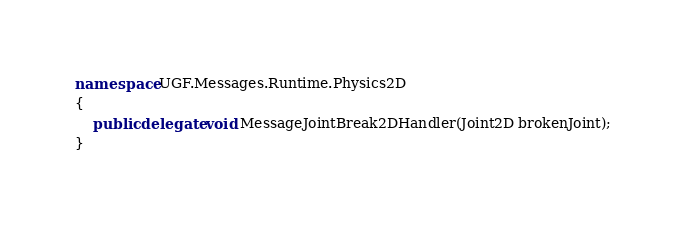Convert code to text. <code><loc_0><loc_0><loc_500><loc_500><_C#_>namespace UGF.Messages.Runtime.Physics2D
{
    public delegate void MessageJointBreak2DHandler(Joint2D brokenJoint);
}
</code> 